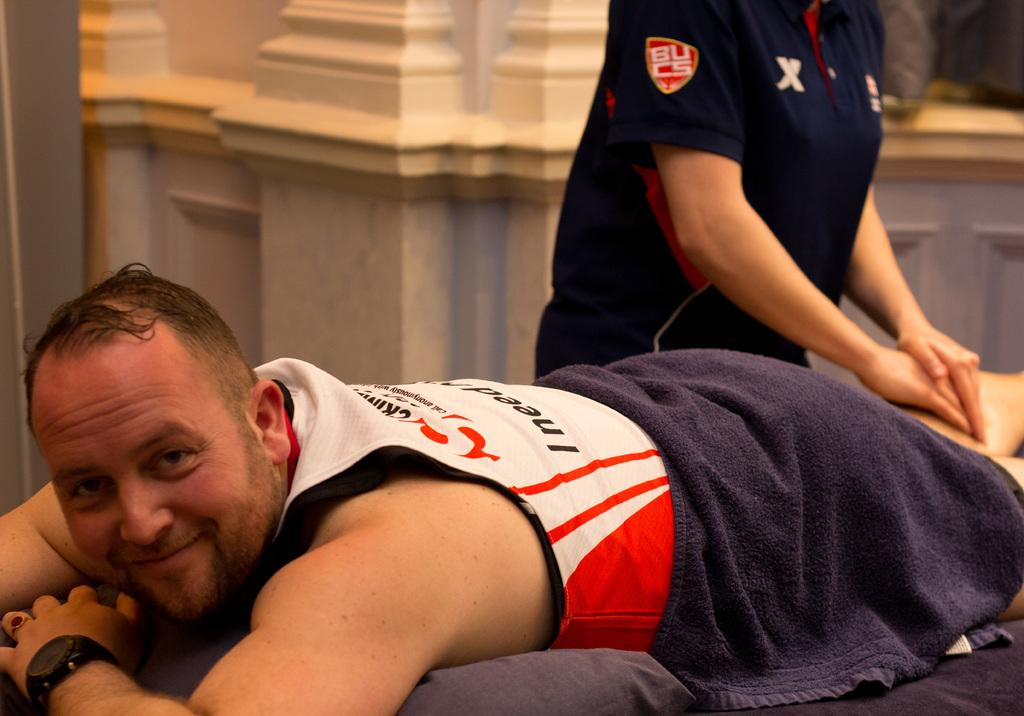What is the main subject of the image? There is a person lying on the bed in the image. What items can be seen on the bed? There is a pillow and a towel on the bed. Can you describe the background of the image? There is another person in the background of the image, and there is a wall visible in the background. What type of bait is being used by the kitty in the image? There is no kitty present in the image, so there is no bait being used. 